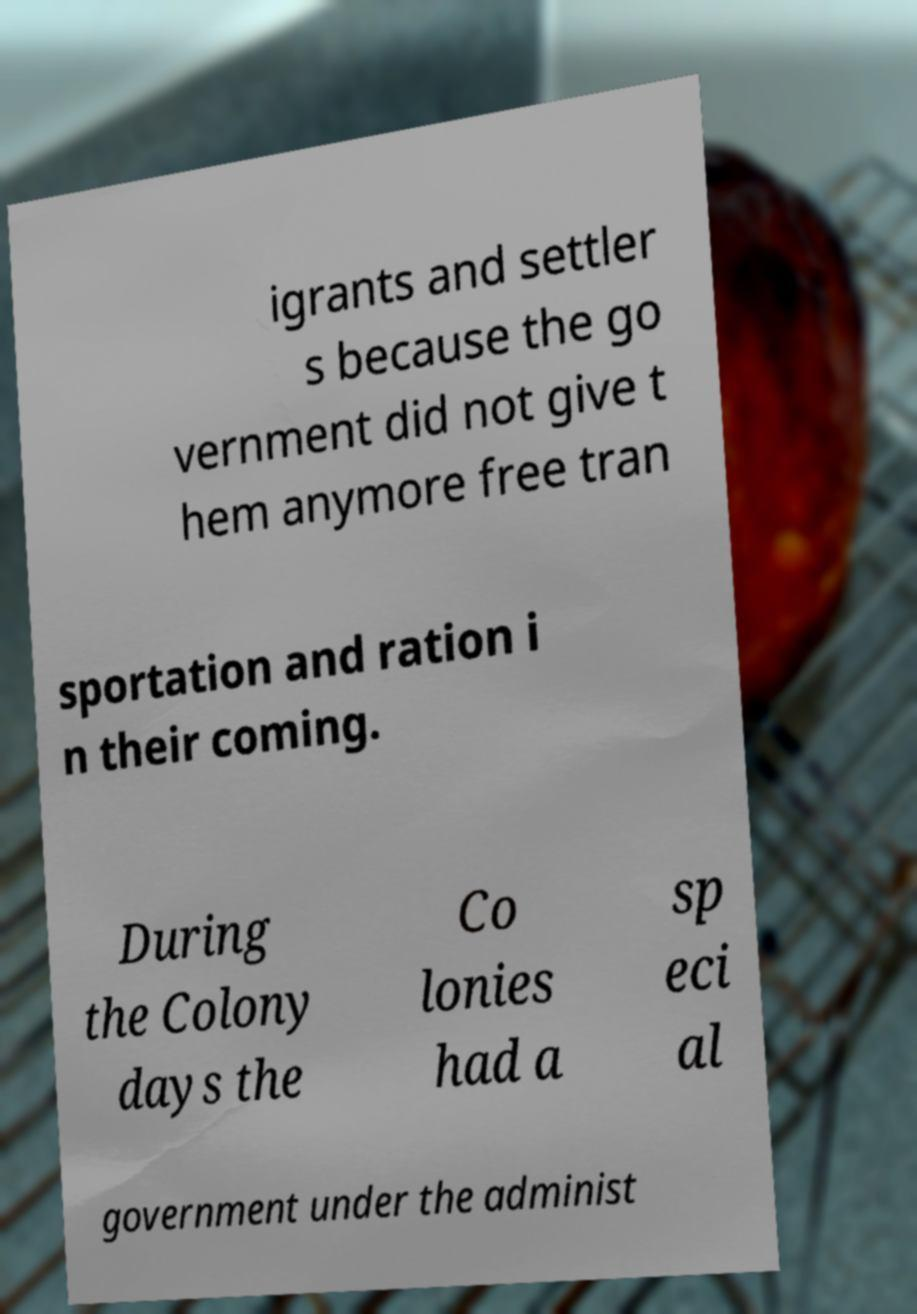Please read and relay the text visible in this image. What does it say? igrants and settler s because the go vernment did not give t hem anymore free tran sportation and ration i n their coming. During the Colony days the Co lonies had a sp eci al government under the administ 